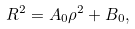Convert formula to latex. <formula><loc_0><loc_0><loc_500><loc_500>R ^ { 2 } = A _ { 0 } \rho ^ { 2 } + B _ { 0 } ,</formula> 